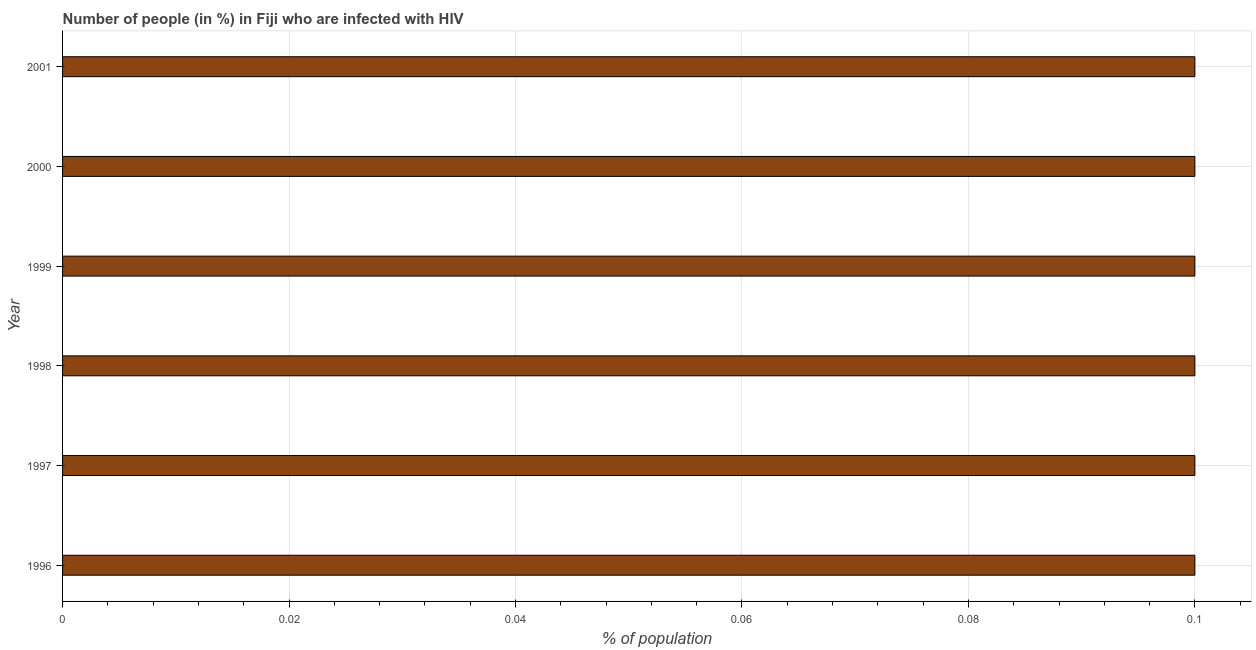Does the graph contain any zero values?
Provide a succinct answer. No. What is the title of the graph?
Offer a very short reply. Number of people (in %) in Fiji who are infected with HIV. What is the label or title of the X-axis?
Make the answer very short. % of population. Across all years, what is the maximum number of people infected with hiv?
Provide a short and direct response. 0.1. Across all years, what is the minimum number of people infected with hiv?
Make the answer very short. 0.1. In which year was the number of people infected with hiv maximum?
Ensure brevity in your answer.  1996. In which year was the number of people infected with hiv minimum?
Give a very brief answer. 1996. What is the difference between the number of people infected with hiv in 1996 and 1997?
Keep it short and to the point. 0. What is the median number of people infected with hiv?
Offer a very short reply. 0.1. Is the difference between the number of people infected with hiv in 1997 and 1999 greater than the difference between any two years?
Your answer should be compact. Yes. What is the difference between the highest and the second highest number of people infected with hiv?
Provide a succinct answer. 0. Is the sum of the number of people infected with hiv in 1997 and 2000 greater than the maximum number of people infected with hiv across all years?
Your answer should be compact. Yes. What is the difference between the highest and the lowest number of people infected with hiv?
Ensure brevity in your answer.  0. In how many years, is the number of people infected with hiv greater than the average number of people infected with hiv taken over all years?
Offer a very short reply. 6. How many bars are there?
Ensure brevity in your answer.  6. How many years are there in the graph?
Your answer should be compact. 6. What is the difference between two consecutive major ticks on the X-axis?
Provide a short and direct response. 0.02. What is the % of population of 1998?
Ensure brevity in your answer.  0.1. What is the difference between the % of population in 1996 and 1999?
Your answer should be compact. 0. What is the difference between the % of population in 1997 and 1999?
Your response must be concise. 0. What is the difference between the % of population in 1997 and 2001?
Your response must be concise. 0. What is the difference between the % of population in 1998 and 1999?
Make the answer very short. 0. What is the difference between the % of population in 1999 and 2000?
Your answer should be very brief. 0. What is the ratio of the % of population in 1996 to that in 1997?
Make the answer very short. 1. What is the ratio of the % of population in 1996 to that in 1999?
Ensure brevity in your answer.  1. What is the ratio of the % of population in 1997 to that in 1998?
Your response must be concise. 1. What is the ratio of the % of population in 1997 to that in 1999?
Offer a very short reply. 1. What is the ratio of the % of population in 1997 to that in 2000?
Make the answer very short. 1. What is the ratio of the % of population in 1998 to that in 1999?
Offer a terse response. 1. What is the ratio of the % of population in 1998 to that in 2001?
Your answer should be very brief. 1. What is the ratio of the % of population in 2000 to that in 2001?
Make the answer very short. 1. 